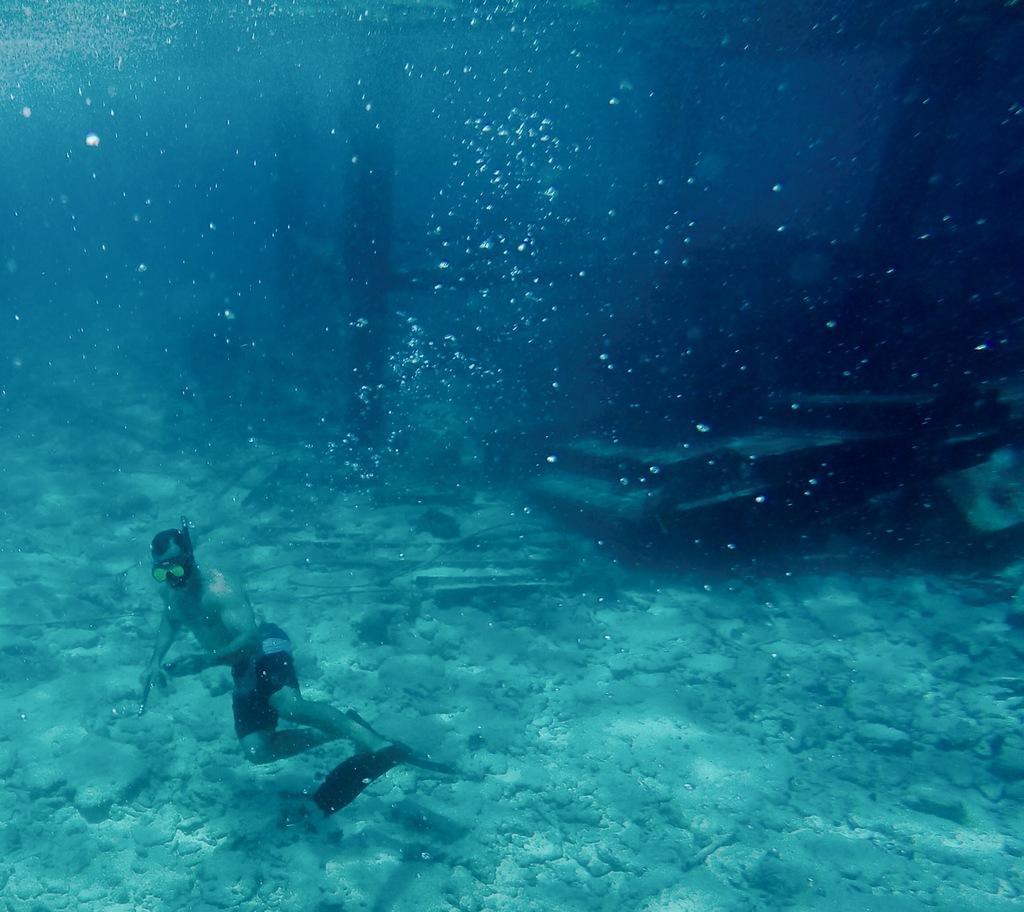Please provide a concise description of this image. There is a person in a short swimming in the water, near stones which are on the ground. In the background, there are other objects on the ground surfaces. And there are air balloons formed in the water of an ocean. 